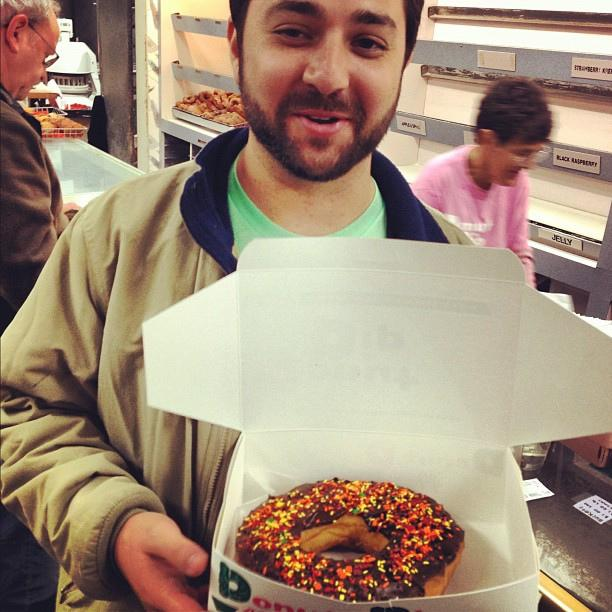What food nutrients are lacking in this food? vitamins 